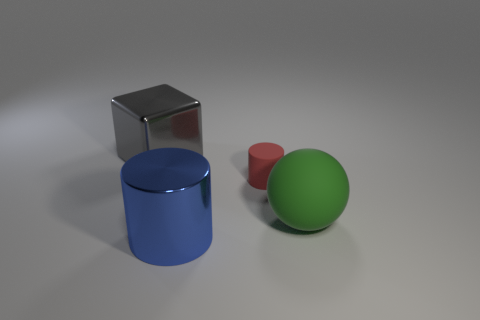What materials appear to be represented by the objects in the image? The objects in the image seem to represent different materials. The large blue cylinder and the smaller red cylinder have a matte finish reminiscent of plastic. The shiny smaller object's reflective surface suggests it is metallic. Finally, the green sphere has a smooth texture, which could be indicative of a painted wooden object or a smooth plastic. 